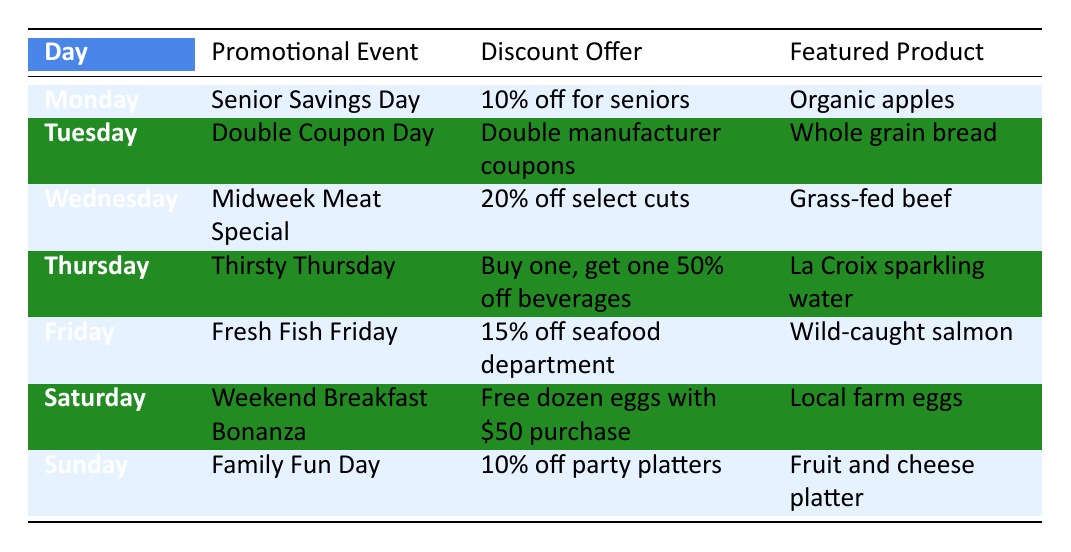What discount do seniors receive on Monday? The table states that on Monday, the promotional event is "Senior Savings Day," which offers a discount of "10% off for seniors."
Answer: 10% off for seniors What is the featured product on Friday? According to the table, on Friday, the featured product is "Wild-caught salmon."
Answer: Wild-caught salmon On which day is there a special offer on beverages? The table indicates that Thursday is the day for the promotional event "Thirsty Thursday," where the discount is "Buy one, get one 50% off beverages."
Answer: Thursday Is there a discount offer for party platters on Sunday? Yes, the table shows that Sunday is "Family Fun Day," and the discount offer is "10% off party platters."
Answer: Yes How much total discount can a customer receive on select cuts of meat on Wednesday compared to Monday's offer? On Wednesday, the discount for select cuts is "20% off," while Monday's offer for seniors is "10% off." The difference is calculated as 20 - 10 = 10. Therefore, the customer receives an additional 10% discount on Wednesday compared to Monday's offer.
Answer: 10% What is the total number of promotional events that offer discounts greater than 10%? The table provides data for seven days. The events offering discounts greater than 10% are: "Midweek Meat Special" (20% off) and "Fresh Fish Friday" (15% off). The counts of such events is therefore 2.
Answer: 2 Which promotional event provides free products, and on what day does this occur? Looking at the table, the promotional event that provides free products is "Weekend Breakfast Bonanza" on Saturday, where customers can receive a "Free dozen eggs with $50 purchase."
Answer: Weekend Breakfast Bonanza on Saturday If a customer shops on Tuesday and buys a product that normally costs $3, what would be the total discount they receive? On Tuesday, the promotional event is "Double Coupon Day," which means customers can double their manufacturer coupons. However, without knowing the coupon value, we can't determine the exact discount. Thus, we can't compute the total discount.
Answer: Cannot determine How does the discount for seafood on Friday compare to that for seniors on Monday? According to the table, Friday offers "15% off seafood department," while Monday offers "10% off for seniors." The comparison of discounts shows that Friday's offer is 5% higher than Monday's offer.
Answer: 5% higher 